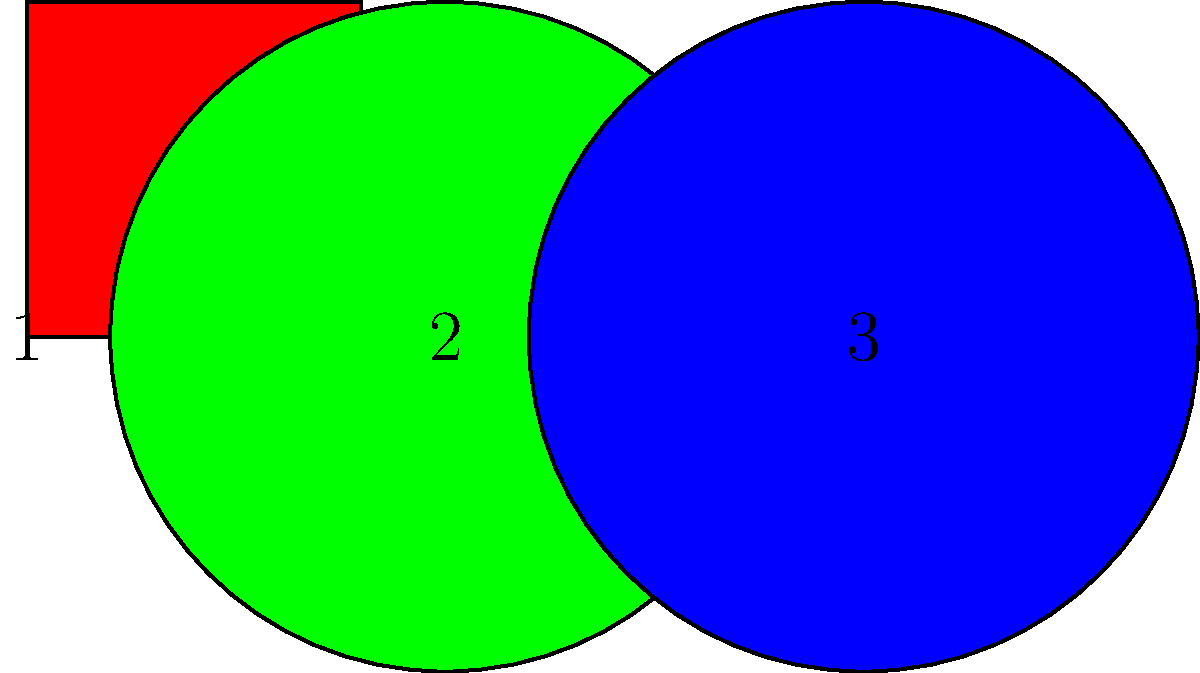You're organizing a fun party game where guests need to arrange colorful shapes. If you have a red square, a green triangle, and a blue circle, how many different ways can you arrange these shapes in a line? Let's approach this step-by-step:

1. We have three different shapes: a red square, a green triangle, and a blue circle.

2. To arrange these shapes in a line, we need to decide the order in which we place them.

3. For the first position, we have 3 choices (any of the three shapes can go first).

4. After placing the first shape, we have 2 choices left for the second position.

5. For the last position, we only have 1 choice left (the remaining shape).

6. In mathematics, when we have a series of choices where the order matters and we use all items, we multiply the number of choices for each position.

7. Therefore, the total number of arrangements is:
   $3 \times 2 \times 1 = 6$

This is also known as the factorial of 3, written as $3!$ in mathematics.
Answer: 6 